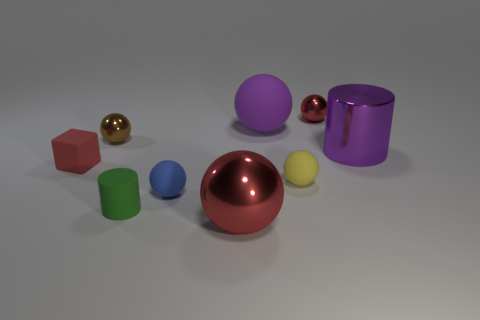Subtract all blue balls. How many balls are left? 5 Subtract all purple cylinders. How many cylinders are left? 1 Subtract 0 gray spheres. How many objects are left? 9 Subtract all cubes. How many objects are left? 8 Subtract 4 spheres. How many spheres are left? 2 Subtract all purple spheres. Subtract all green blocks. How many spheres are left? 5 Subtract all blue spheres. How many brown cubes are left? 0 Subtract all big red shiny cubes. Subtract all tiny green matte cylinders. How many objects are left? 8 Add 4 matte cylinders. How many matte cylinders are left? 5 Add 3 red metallic balls. How many red metallic balls exist? 5 